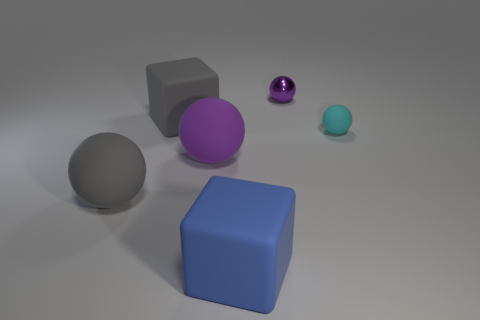Do the cyan object and the large blue rubber object have the same shape?
Your answer should be very brief. No. What number of other objects are the same color as the metal object?
Ensure brevity in your answer.  1. Does the cube that is in front of the tiny cyan rubber sphere have the same size as the gray thing that is behind the large gray ball?
Your answer should be compact. Yes. Is the number of gray blocks that are behind the small cyan thing the same as the number of small purple things in front of the tiny purple shiny sphere?
Provide a short and direct response. No. Is there anything else that has the same material as the small purple object?
Your answer should be very brief. No. Is the size of the blue rubber cube the same as the rubber ball that is on the right side of the purple metallic thing?
Ensure brevity in your answer.  No. What material is the block behind the blue matte block that is on the right side of the large gray cube made of?
Keep it short and to the point. Rubber. Is the number of shiny spheres right of the small purple metallic thing the same as the number of tiny green matte things?
Provide a succinct answer. Yes. What is the size of the thing that is to the right of the large blue matte object and on the left side of the cyan rubber thing?
Keep it short and to the point. Small. There is a block that is behind the large gray object in front of the gray block; what is its color?
Your answer should be compact. Gray. 